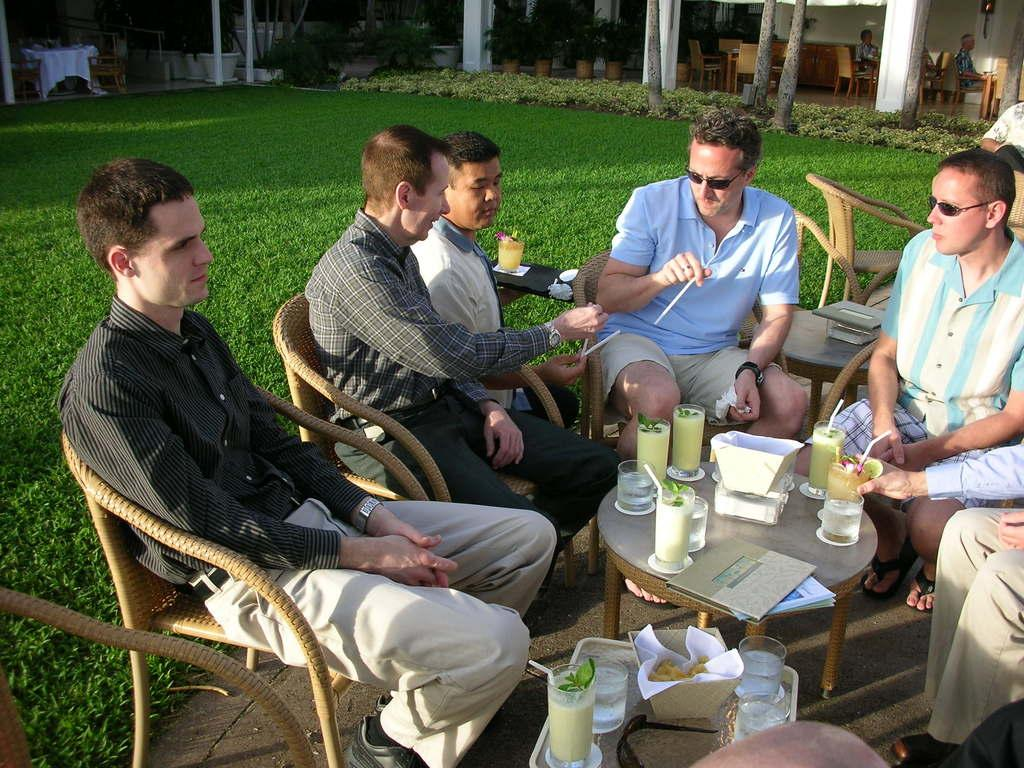How many people are in the image? There is a group of people in the image. What are the people doing in the image? The people are sitting in chairs. What is on the table in the image? There is a glass, a paper, a book, and tissues on the table. What can be seen in the background of the image? There are plants, grass, and a house in the background of the image. What type of adjustment can be seen on the people's flesh in the image? There is no mention of any adjustment or flesh in the image; it features a group of people sitting in chairs with a table and background elements. 